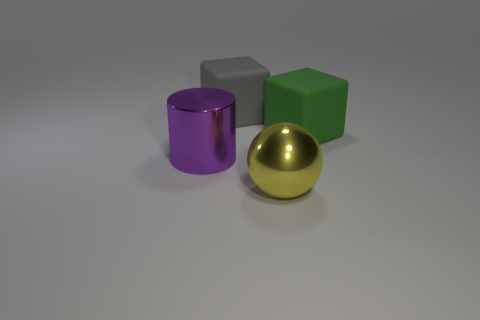Add 3 purple metal things. How many objects exist? 7 Subtract all cylinders. How many objects are left? 3 Add 1 yellow metallic objects. How many yellow metallic objects exist? 2 Subtract 0 green cylinders. How many objects are left? 4 Subtract all big brown balls. Subtract all spheres. How many objects are left? 3 Add 4 large yellow things. How many large yellow things are left? 5 